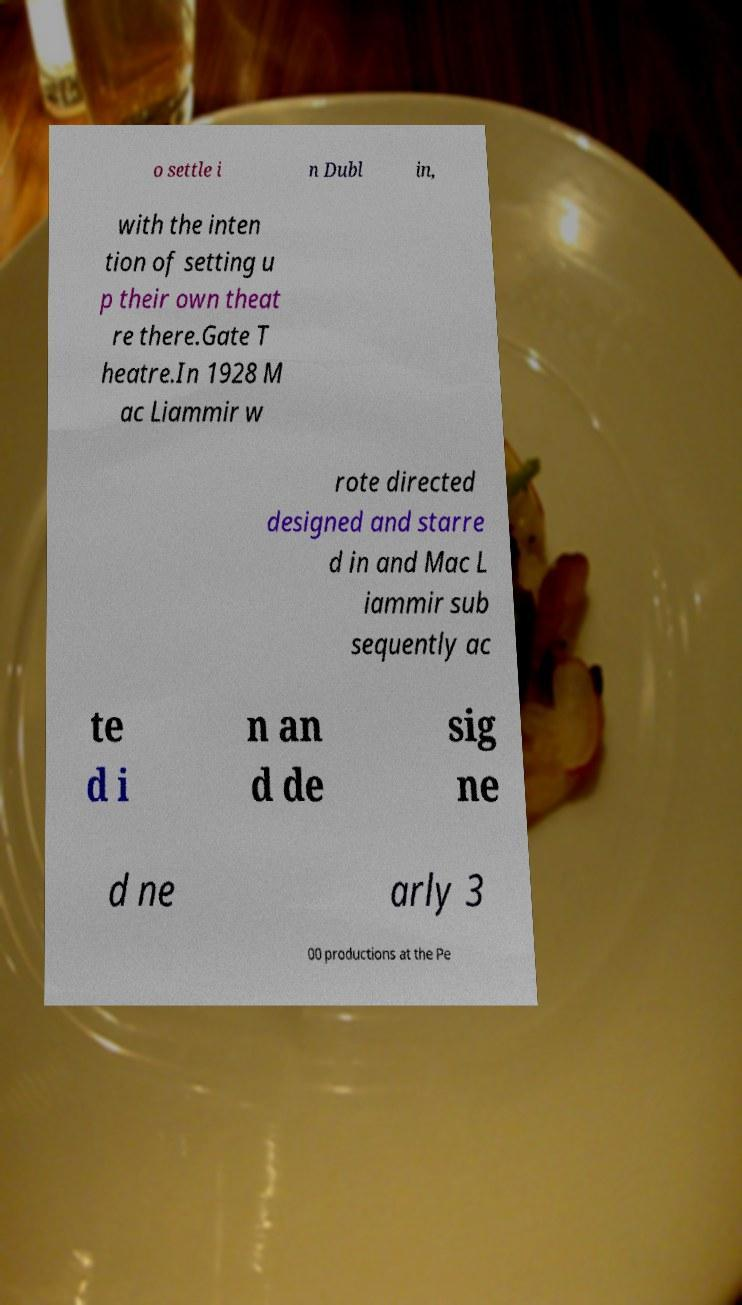For documentation purposes, I need the text within this image transcribed. Could you provide that? o settle i n Dubl in, with the inten tion of setting u p their own theat re there.Gate T heatre.In 1928 M ac Liammir w rote directed designed and starre d in and Mac L iammir sub sequently ac te d i n an d de sig ne d ne arly 3 00 productions at the Pe 